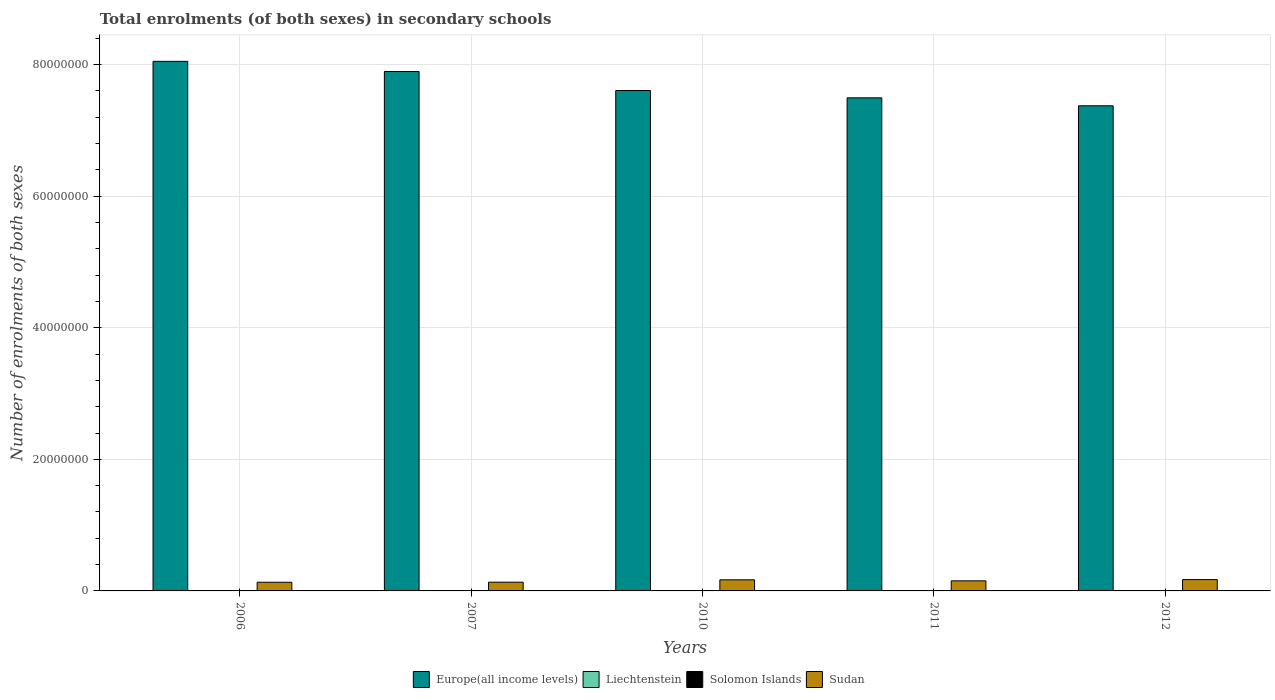How many different coloured bars are there?
Your response must be concise. 4. Are the number of bars per tick equal to the number of legend labels?
Give a very brief answer. Yes. How many bars are there on the 3rd tick from the left?
Ensure brevity in your answer.  4. How many bars are there on the 5th tick from the right?
Provide a short and direct response. 4. What is the number of enrolments in secondary schools in Liechtenstein in 2007?
Your answer should be very brief. 3169. Across all years, what is the maximum number of enrolments in secondary schools in Solomon Islands?
Your response must be concise. 4.17e+04. Across all years, what is the minimum number of enrolments in secondary schools in Liechtenstein?
Offer a terse response. 3169. In which year was the number of enrolments in secondary schools in Sudan maximum?
Give a very brief answer. 2012. What is the total number of enrolments in secondary schools in Solomon Islands in the graph?
Give a very brief answer. 1.75e+05. What is the difference between the number of enrolments in secondary schools in Europe(all income levels) in 2006 and that in 2012?
Give a very brief answer. 6.75e+06. What is the difference between the number of enrolments in secondary schools in Europe(all income levels) in 2010 and the number of enrolments in secondary schools in Sudan in 2006?
Offer a terse response. 7.47e+07. What is the average number of enrolments in secondary schools in Solomon Islands per year?
Keep it short and to the point. 3.50e+04. In the year 2006, what is the difference between the number of enrolments in secondary schools in Sudan and number of enrolments in secondary schools in Solomon Islands?
Provide a short and direct response. 1.29e+06. What is the ratio of the number of enrolments in secondary schools in Solomon Islands in 2011 to that in 2012?
Your answer should be compact. 0.96. Is the number of enrolments in secondary schools in Europe(all income levels) in 2006 less than that in 2007?
Keep it short and to the point. No. What is the difference between the highest and the second highest number of enrolments in secondary schools in Liechtenstein?
Your answer should be very brief. 21. What is the difference between the highest and the lowest number of enrolments in secondary schools in Sudan?
Your answer should be very brief. 4.06e+05. In how many years, is the number of enrolments in secondary schools in Liechtenstein greater than the average number of enrolments in secondary schools in Liechtenstein taken over all years?
Ensure brevity in your answer.  3. Is it the case that in every year, the sum of the number of enrolments in secondary schools in Europe(all income levels) and number of enrolments in secondary schools in Liechtenstein is greater than the sum of number of enrolments in secondary schools in Solomon Islands and number of enrolments in secondary schools in Sudan?
Your answer should be compact. Yes. What does the 4th bar from the left in 2012 represents?
Provide a short and direct response. Sudan. What does the 1st bar from the right in 2010 represents?
Ensure brevity in your answer.  Sudan. How many years are there in the graph?
Offer a terse response. 5. What is the difference between two consecutive major ticks on the Y-axis?
Give a very brief answer. 2.00e+07. Are the values on the major ticks of Y-axis written in scientific E-notation?
Your answer should be very brief. No. Does the graph contain any zero values?
Make the answer very short. No. What is the title of the graph?
Provide a succinct answer. Total enrolments (of both sexes) in secondary schools. Does "Bahrain" appear as one of the legend labels in the graph?
Offer a very short reply. No. What is the label or title of the Y-axis?
Your response must be concise. Number of enrolments of both sexes. What is the Number of enrolments of both sexes of Europe(all income levels) in 2006?
Your answer should be very brief. 8.05e+07. What is the Number of enrolments of both sexes in Liechtenstein in 2006?
Provide a succinct answer. 3190. What is the Number of enrolments of both sexes of Solomon Islands in 2006?
Offer a very short reply. 2.63e+04. What is the Number of enrolments of both sexes in Sudan in 2006?
Your answer should be very brief. 1.32e+06. What is the Number of enrolments of both sexes of Europe(all income levels) in 2007?
Offer a very short reply. 7.90e+07. What is the Number of enrolments of both sexes in Liechtenstein in 2007?
Make the answer very short. 3169. What is the Number of enrolments of both sexes of Solomon Islands in 2007?
Offer a very short reply. 2.73e+04. What is the Number of enrolments of both sexes of Sudan in 2007?
Ensure brevity in your answer.  1.33e+06. What is the Number of enrolments of both sexes of Europe(all income levels) in 2010?
Your answer should be compact. 7.61e+07. What is the Number of enrolments of both sexes in Liechtenstein in 2010?
Make the answer very short. 3274. What is the Number of enrolments of both sexes in Solomon Islands in 2010?
Keep it short and to the point. 3.97e+04. What is the Number of enrolments of both sexes in Sudan in 2010?
Your response must be concise. 1.69e+06. What is the Number of enrolments of both sexes in Europe(all income levels) in 2011?
Make the answer very short. 7.50e+07. What is the Number of enrolments of both sexes in Liechtenstein in 2011?
Provide a short and direct response. 3298. What is the Number of enrolments of both sexes of Solomon Islands in 2011?
Offer a very short reply. 4.01e+04. What is the Number of enrolments of both sexes of Sudan in 2011?
Keep it short and to the point. 1.53e+06. What is the Number of enrolments of both sexes in Europe(all income levels) in 2012?
Offer a very short reply. 7.37e+07. What is the Number of enrolments of both sexes of Liechtenstein in 2012?
Your response must be concise. 3277. What is the Number of enrolments of both sexes in Solomon Islands in 2012?
Your response must be concise. 4.17e+04. What is the Number of enrolments of both sexes in Sudan in 2012?
Provide a succinct answer. 1.72e+06. Across all years, what is the maximum Number of enrolments of both sexes of Europe(all income levels)?
Offer a terse response. 8.05e+07. Across all years, what is the maximum Number of enrolments of both sexes in Liechtenstein?
Keep it short and to the point. 3298. Across all years, what is the maximum Number of enrolments of both sexes in Solomon Islands?
Your answer should be very brief. 4.17e+04. Across all years, what is the maximum Number of enrolments of both sexes in Sudan?
Your answer should be compact. 1.72e+06. Across all years, what is the minimum Number of enrolments of both sexes of Europe(all income levels)?
Ensure brevity in your answer.  7.37e+07. Across all years, what is the minimum Number of enrolments of both sexes in Liechtenstein?
Offer a terse response. 3169. Across all years, what is the minimum Number of enrolments of both sexes of Solomon Islands?
Offer a very short reply. 2.63e+04. Across all years, what is the minimum Number of enrolments of both sexes in Sudan?
Provide a short and direct response. 1.32e+06. What is the total Number of enrolments of both sexes of Europe(all income levels) in the graph?
Your response must be concise. 3.84e+08. What is the total Number of enrolments of both sexes in Liechtenstein in the graph?
Ensure brevity in your answer.  1.62e+04. What is the total Number of enrolments of both sexes of Solomon Islands in the graph?
Make the answer very short. 1.75e+05. What is the total Number of enrolments of both sexes in Sudan in the graph?
Your answer should be compact. 7.59e+06. What is the difference between the Number of enrolments of both sexes in Europe(all income levels) in 2006 and that in 2007?
Offer a terse response. 1.54e+06. What is the difference between the Number of enrolments of both sexes of Liechtenstein in 2006 and that in 2007?
Offer a very short reply. 21. What is the difference between the Number of enrolments of both sexes of Solomon Islands in 2006 and that in 2007?
Offer a terse response. -987. What is the difference between the Number of enrolments of both sexes in Sudan in 2006 and that in 2007?
Ensure brevity in your answer.  -9811. What is the difference between the Number of enrolments of both sexes of Europe(all income levels) in 2006 and that in 2010?
Keep it short and to the point. 4.43e+06. What is the difference between the Number of enrolments of both sexes in Liechtenstein in 2006 and that in 2010?
Provide a short and direct response. -84. What is the difference between the Number of enrolments of both sexes in Solomon Islands in 2006 and that in 2010?
Your answer should be compact. -1.34e+04. What is the difference between the Number of enrolments of both sexes of Sudan in 2006 and that in 2010?
Your answer should be very brief. -3.69e+05. What is the difference between the Number of enrolments of both sexes in Europe(all income levels) in 2006 and that in 2011?
Your response must be concise. 5.55e+06. What is the difference between the Number of enrolments of both sexes of Liechtenstein in 2006 and that in 2011?
Make the answer very short. -108. What is the difference between the Number of enrolments of both sexes in Solomon Islands in 2006 and that in 2011?
Offer a very short reply. -1.38e+04. What is the difference between the Number of enrolments of both sexes of Sudan in 2006 and that in 2011?
Offer a terse response. -2.13e+05. What is the difference between the Number of enrolments of both sexes of Europe(all income levels) in 2006 and that in 2012?
Provide a short and direct response. 6.75e+06. What is the difference between the Number of enrolments of both sexes in Liechtenstein in 2006 and that in 2012?
Provide a succinct answer. -87. What is the difference between the Number of enrolments of both sexes of Solomon Islands in 2006 and that in 2012?
Keep it short and to the point. -1.53e+04. What is the difference between the Number of enrolments of both sexes of Sudan in 2006 and that in 2012?
Your answer should be compact. -4.06e+05. What is the difference between the Number of enrolments of both sexes of Europe(all income levels) in 2007 and that in 2010?
Make the answer very short. 2.89e+06. What is the difference between the Number of enrolments of both sexes of Liechtenstein in 2007 and that in 2010?
Your answer should be compact. -105. What is the difference between the Number of enrolments of both sexes in Solomon Islands in 2007 and that in 2010?
Your answer should be compact. -1.24e+04. What is the difference between the Number of enrolments of both sexes of Sudan in 2007 and that in 2010?
Your answer should be compact. -3.59e+05. What is the difference between the Number of enrolments of both sexes of Europe(all income levels) in 2007 and that in 2011?
Provide a short and direct response. 4.01e+06. What is the difference between the Number of enrolments of both sexes of Liechtenstein in 2007 and that in 2011?
Give a very brief answer. -129. What is the difference between the Number of enrolments of both sexes in Solomon Islands in 2007 and that in 2011?
Keep it short and to the point. -1.28e+04. What is the difference between the Number of enrolments of both sexes of Sudan in 2007 and that in 2011?
Your answer should be very brief. -2.03e+05. What is the difference between the Number of enrolments of both sexes of Europe(all income levels) in 2007 and that in 2012?
Your response must be concise. 5.21e+06. What is the difference between the Number of enrolments of both sexes of Liechtenstein in 2007 and that in 2012?
Give a very brief answer. -108. What is the difference between the Number of enrolments of both sexes of Solomon Islands in 2007 and that in 2012?
Provide a short and direct response. -1.43e+04. What is the difference between the Number of enrolments of both sexes in Sudan in 2007 and that in 2012?
Keep it short and to the point. -3.96e+05. What is the difference between the Number of enrolments of both sexes of Europe(all income levels) in 2010 and that in 2011?
Keep it short and to the point. 1.11e+06. What is the difference between the Number of enrolments of both sexes of Liechtenstein in 2010 and that in 2011?
Make the answer very short. -24. What is the difference between the Number of enrolments of both sexes in Solomon Islands in 2010 and that in 2011?
Keep it short and to the point. -418. What is the difference between the Number of enrolments of both sexes in Sudan in 2010 and that in 2011?
Keep it short and to the point. 1.57e+05. What is the difference between the Number of enrolments of both sexes of Europe(all income levels) in 2010 and that in 2012?
Offer a terse response. 2.32e+06. What is the difference between the Number of enrolments of both sexes in Liechtenstein in 2010 and that in 2012?
Give a very brief answer. -3. What is the difference between the Number of enrolments of both sexes of Solomon Islands in 2010 and that in 2012?
Your response must be concise. -1954. What is the difference between the Number of enrolments of both sexes of Sudan in 2010 and that in 2012?
Your response must be concise. -3.63e+04. What is the difference between the Number of enrolments of both sexes in Europe(all income levels) in 2011 and that in 2012?
Keep it short and to the point. 1.21e+06. What is the difference between the Number of enrolments of both sexes in Solomon Islands in 2011 and that in 2012?
Ensure brevity in your answer.  -1536. What is the difference between the Number of enrolments of both sexes in Sudan in 2011 and that in 2012?
Offer a terse response. -1.93e+05. What is the difference between the Number of enrolments of both sexes of Europe(all income levels) in 2006 and the Number of enrolments of both sexes of Liechtenstein in 2007?
Give a very brief answer. 8.05e+07. What is the difference between the Number of enrolments of both sexes in Europe(all income levels) in 2006 and the Number of enrolments of both sexes in Solomon Islands in 2007?
Keep it short and to the point. 8.05e+07. What is the difference between the Number of enrolments of both sexes of Europe(all income levels) in 2006 and the Number of enrolments of both sexes of Sudan in 2007?
Keep it short and to the point. 7.92e+07. What is the difference between the Number of enrolments of both sexes of Liechtenstein in 2006 and the Number of enrolments of both sexes of Solomon Islands in 2007?
Provide a succinct answer. -2.41e+04. What is the difference between the Number of enrolments of both sexes of Liechtenstein in 2006 and the Number of enrolments of both sexes of Sudan in 2007?
Keep it short and to the point. -1.32e+06. What is the difference between the Number of enrolments of both sexes of Solomon Islands in 2006 and the Number of enrolments of both sexes of Sudan in 2007?
Provide a short and direct response. -1.30e+06. What is the difference between the Number of enrolments of both sexes of Europe(all income levels) in 2006 and the Number of enrolments of both sexes of Liechtenstein in 2010?
Your response must be concise. 8.05e+07. What is the difference between the Number of enrolments of both sexes of Europe(all income levels) in 2006 and the Number of enrolments of both sexes of Solomon Islands in 2010?
Keep it short and to the point. 8.05e+07. What is the difference between the Number of enrolments of both sexes of Europe(all income levels) in 2006 and the Number of enrolments of both sexes of Sudan in 2010?
Keep it short and to the point. 7.88e+07. What is the difference between the Number of enrolments of both sexes in Liechtenstein in 2006 and the Number of enrolments of both sexes in Solomon Islands in 2010?
Offer a terse response. -3.65e+04. What is the difference between the Number of enrolments of both sexes of Liechtenstein in 2006 and the Number of enrolments of both sexes of Sudan in 2010?
Your response must be concise. -1.68e+06. What is the difference between the Number of enrolments of both sexes in Solomon Islands in 2006 and the Number of enrolments of both sexes in Sudan in 2010?
Offer a very short reply. -1.66e+06. What is the difference between the Number of enrolments of both sexes of Europe(all income levels) in 2006 and the Number of enrolments of both sexes of Liechtenstein in 2011?
Ensure brevity in your answer.  8.05e+07. What is the difference between the Number of enrolments of both sexes in Europe(all income levels) in 2006 and the Number of enrolments of both sexes in Solomon Islands in 2011?
Your answer should be compact. 8.05e+07. What is the difference between the Number of enrolments of both sexes of Europe(all income levels) in 2006 and the Number of enrolments of both sexes of Sudan in 2011?
Your response must be concise. 7.90e+07. What is the difference between the Number of enrolments of both sexes in Liechtenstein in 2006 and the Number of enrolments of both sexes in Solomon Islands in 2011?
Provide a succinct answer. -3.69e+04. What is the difference between the Number of enrolments of both sexes of Liechtenstein in 2006 and the Number of enrolments of both sexes of Sudan in 2011?
Keep it short and to the point. -1.53e+06. What is the difference between the Number of enrolments of both sexes of Solomon Islands in 2006 and the Number of enrolments of both sexes of Sudan in 2011?
Provide a succinct answer. -1.50e+06. What is the difference between the Number of enrolments of both sexes in Europe(all income levels) in 2006 and the Number of enrolments of both sexes in Liechtenstein in 2012?
Make the answer very short. 8.05e+07. What is the difference between the Number of enrolments of both sexes in Europe(all income levels) in 2006 and the Number of enrolments of both sexes in Solomon Islands in 2012?
Keep it short and to the point. 8.05e+07. What is the difference between the Number of enrolments of both sexes in Europe(all income levels) in 2006 and the Number of enrolments of both sexes in Sudan in 2012?
Your response must be concise. 7.88e+07. What is the difference between the Number of enrolments of both sexes of Liechtenstein in 2006 and the Number of enrolments of both sexes of Solomon Islands in 2012?
Provide a short and direct response. -3.85e+04. What is the difference between the Number of enrolments of both sexes of Liechtenstein in 2006 and the Number of enrolments of both sexes of Sudan in 2012?
Your answer should be compact. -1.72e+06. What is the difference between the Number of enrolments of both sexes in Solomon Islands in 2006 and the Number of enrolments of both sexes in Sudan in 2012?
Make the answer very short. -1.70e+06. What is the difference between the Number of enrolments of both sexes of Europe(all income levels) in 2007 and the Number of enrolments of both sexes of Liechtenstein in 2010?
Make the answer very short. 7.90e+07. What is the difference between the Number of enrolments of both sexes in Europe(all income levels) in 2007 and the Number of enrolments of both sexes in Solomon Islands in 2010?
Offer a terse response. 7.89e+07. What is the difference between the Number of enrolments of both sexes of Europe(all income levels) in 2007 and the Number of enrolments of both sexes of Sudan in 2010?
Your response must be concise. 7.73e+07. What is the difference between the Number of enrolments of both sexes in Liechtenstein in 2007 and the Number of enrolments of both sexes in Solomon Islands in 2010?
Offer a very short reply. -3.65e+04. What is the difference between the Number of enrolments of both sexes in Liechtenstein in 2007 and the Number of enrolments of both sexes in Sudan in 2010?
Give a very brief answer. -1.68e+06. What is the difference between the Number of enrolments of both sexes of Solomon Islands in 2007 and the Number of enrolments of both sexes of Sudan in 2010?
Give a very brief answer. -1.66e+06. What is the difference between the Number of enrolments of both sexes in Europe(all income levels) in 2007 and the Number of enrolments of both sexes in Liechtenstein in 2011?
Your response must be concise. 7.90e+07. What is the difference between the Number of enrolments of both sexes in Europe(all income levels) in 2007 and the Number of enrolments of both sexes in Solomon Islands in 2011?
Your answer should be compact. 7.89e+07. What is the difference between the Number of enrolments of both sexes of Europe(all income levels) in 2007 and the Number of enrolments of both sexes of Sudan in 2011?
Your response must be concise. 7.74e+07. What is the difference between the Number of enrolments of both sexes in Liechtenstein in 2007 and the Number of enrolments of both sexes in Solomon Islands in 2011?
Give a very brief answer. -3.70e+04. What is the difference between the Number of enrolments of both sexes of Liechtenstein in 2007 and the Number of enrolments of both sexes of Sudan in 2011?
Give a very brief answer. -1.53e+06. What is the difference between the Number of enrolments of both sexes of Solomon Islands in 2007 and the Number of enrolments of both sexes of Sudan in 2011?
Ensure brevity in your answer.  -1.50e+06. What is the difference between the Number of enrolments of both sexes of Europe(all income levels) in 2007 and the Number of enrolments of both sexes of Liechtenstein in 2012?
Offer a very short reply. 7.90e+07. What is the difference between the Number of enrolments of both sexes in Europe(all income levels) in 2007 and the Number of enrolments of both sexes in Solomon Islands in 2012?
Your response must be concise. 7.89e+07. What is the difference between the Number of enrolments of both sexes in Europe(all income levels) in 2007 and the Number of enrolments of both sexes in Sudan in 2012?
Your answer should be very brief. 7.72e+07. What is the difference between the Number of enrolments of both sexes of Liechtenstein in 2007 and the Number of enrolments of both sexes of Solomon Islands in 2012?
Your response must be concise. -3.85e+04. What is the difference between the Number of enrolments of both sexes in Liechtenstein in 2007 and the Number of enrolments of both sexes in Sudan in 2012?
Make the answer very short. -1.72e+06. What is the difference between the Number of enrolments of both sexes in Solomon Islands in 2007 and the Number of enrolments of both sexes in Sudan in 2012?
Provide a short and direct response. -1.70e+06. What is the difference between the Number of enrolments of both sexes in Europe(all income levels) in 2010 and the Number of enrolments of both sexes in Liechtenstein in 2011?
Provide a succinct answer. 7.61e+07. What is the difference between the Number of enrolments of both sexes of Europe(all income levels) in 2010 and the Number of enrolments of both sexes of Solomon Islands in 2011?
Provide a short and direct response. 7.60e+07. What is the difference between the Number of enrolments of both sexes in Europe(all income levels) in 2010 and the Number of enrolments of both sexes in Sudan in 2011?
Give a very brief answer. 7.45e+07. What is the difference between the Number of enrolments of both sexes in Liechtenstein in 2010 and the Number of enrolments of both sexes in Solomon Islands in 2011?
Ensure brevity in your answer.  -3.68e+04. What is the difference between the Number of enrolments of both sexes in Liechtenstein in 2010 and the Number of enrolments of both sexes in Sudan in 2011?
Offer a terse response. -1.53e+06. What is the difference between the Number of enrolments of both sexes in Solomon Islands in 2010 and the Number of enrolments of both sexes in Sudan in 2011?
Provide a succinct answer. -1.49e+06. What is the difference between the Number of enrolments of both sexes of Europe(all income levels) in 2010 and the Number of enrolments of both sexes of Liechtenstein in 2012?
Your response must be concise. 7.61e+07. What is the difference between the Number of enrolments of both sexes of Europe(all income levels) in 2010 and the Number of enrolments of both sexes of Solomon Islands in 2012?
Your answer should be very brief. 7.60e+07. What is the difference between the Number of enrolments of both sexes of Europe(all income levels) in 2010 and the Number of enrolments of both sexes of Sudan in 2012?
Your answer should be compact. 7.43e+07. What is the difference between the Number of enrolments of both sexes of Liechtenstein in 2010 and the Number of enrolments of both sexes of Solomon Islands in 2012?
Offer a terse response. -3.84e+04. What is the difference between the Number of enrolments of both sexes in Liechtenstein in 2010 and the Number of enrolments of both sexes in Sudan in 2012?
Offer a terse response. -1.72e+06. What is the difference between the Number of enrolments of both sexes in Solomon Islands in 2010 and the Number of enrolments of both sexes in Sudan in 2012?
Your answer should be very brief. -1.68e+06. What is the difference between the Number of enrolments of both sexes of Europe(all income levels) in 2011 and the Number of enrolments of both sexes of Liechtenstein in 2012?
Offer a terse response. 7.49e+07. What is the difference between the Number of enrolments of both sexes in Europe(all income levels) in 2011 and the Number of enrolments of both sexes in Solomon Islands in 2012?
Your answer should be compact. 7.49e+07. What is the difference between the Number of enrolments of both sexes of Europe(all income levels) in 2011 and the Number of enrolments of both sexes of Sudan in 2012?
Your response must be concise. 7.32e+07. What is the difference between the Number of enrolments of both sexes of Liechtenstein in 2011 and the Number of enrolments of both sexes of Solomon Islands in 2012?
Offer a terse response. -3.84e+04. What is the difference between the Number of enrolments of both sexes of Liechtenstein in 2011 and the Number of enrolments of both sexes of Sudan in 2012?
Offer a very short reply. -1.72e+06. What is the difference between the Number of enrolments of both sexes in Solomon Islands in 2011 and the Number of enrolments of both sexes in Sudan in 2012?
Offer a very short reply. -1.68e+06. What is the average Number of enrolments of both sexes of Europe(all income levels) per year?
Offer a very short reply. 7.68e+07. What is the average Number of enrolments of both sexes in Liechtenstein per year?
Ensure brevity in your answer.  3241.6. What is the average Number of enrolments of both sexes of Solomon Islands per year?
Your answer should be very brief. 3.50e+04. What is the average Number of enrolments of both sexes in Sudan per year?
Provide a short and direct response. 1.52e+06. In the year 2006, what is the difference between the Number of enrolments of both sexes in Europe(all income levels) and Number of enrolments of both sexes in Liechtenstein?
Your answer should be very brief. 8.05e+07. In the year 2006, what is the difference between the Number of enrolments of both sexes of Europe(all income levels) and Number of enrolments of both sexes of Solomon Islands?
Offer a very short reply. 8.05e+07. In the year 2006, what is the difference between the Number of enrolments of both sexes in Europe(all income levels) and Number of enrolments of both sexes in Sudan?
Your answer should be compact. 7.92e+07. In the year 2006, what is the difference between the Number of enrolments of both sexes in Liechtenstein and Number of enrolments of both sexes in Solomon Islands?
Keep it short and to the point. -2.32e+04. In the year 2006, what is the difference between the Number of enrolments of both sexes of Liechtenstein and Number of enrolments of both sexes of Sudan?
Your answer should be compact. -1.31e+06. In the year 2006, what is the difference between the Number of enrolments of both sexes in Solomon Islands and Number of enrolments of both sexes in Sudan?
Provide a succinct answer. -1.29e+06. In the year 2007, what is the difference between the Number of enrolments of both sexes of Europe(all income levels) and Number of enrolments of both sexes of Liechtenstein?
Provide a short and direct response. 7.90e+07. In the year 2007, what is the difference between the Number of enrolments of both sexes of Europe(all income levels) and Number of enrolments of both sexes of Solomon Islands?
Keep it short and to the point. 7.89e+07. In the year 2007, what is the difference between the Number of enrolments of both sexes in Europe(all income levels) and Number of enrolments of both sexes in Sudan?
Provide a succinct answer. 7.76e+07. In the year 2007, what is the difference between the Number of enrolments of both sexes in Liechtenstein and Number of enrolments of both sexes in Solomon Islands?
Provide a short and direct response. -2.42e+04. In the year 2007, what is the difference between the Number of enrolments of both sexes in Liechtenstein and Number of enrolments of both sexes in Sudan?
Provide a succinct answer. -1.32e+06. In the year 2007, what is the difference between the Number of enrolments of both sexes of Solomon Islands and Number of enrolments of both sexes of Sudan?
Provide a short and direct response. -1.30e+06. In the year 2010, what is the difference between the Number of enrolments of both sexes in Europe(all income levels) and Number of enrolments of both sexes in Liechtenstein?
Your answer should be very brief. 7.61e+07. In the year 2010, what is the difference between the Number of enrolments of both sexes of Europe(all income levels) and Number of enrolments of both sexes of Solomon Islands?
Provide a succinct answer. 7.60e+07. In the year 2010, what is the difference between the Number of enrolments of both sexes in Europe(all income levels) and Number of enrolments of both sexes in Sudan?
Offer a very short reply. 7.44e+07. In the year 2010, what is the difference between the Number of enrolments of both sexes in Liechtenstein and Number of enrolments of both sexes in Solomon Islands?
Give a very brief answer. -3.64e+04. In the year 2010, what is the difference between the Number of enrolments of both sexes of Liechtenstein and Number of enrolments of both sexes of Sudan?
Your answer should be compact. -1.68e+06. In the year 2010, what is the difference between the Number of enrolments of both sexes of Solomon Islands and Number of enrolments of both sexes of Sudan?
Ensure brevity in your answer.  -1.65e+06. In the year 2011, what is the difference between the Number of enrolments of both sexes in Europe(all income levels) and Number of enrolments of both sexes in Liechtenstein?
Your answer should be compact. 7.49e+07. In the year 2011, what is the difference between the Number of enrolments of both sexes of Europe(all income levels) and Number of enrolments of both sexes of Solomon Islands?
Make the answer very short. 7.49e+07. In the year 2011, what is the difference between the Number of enrolments of both sexes of Europe(all income levels) and Number of enrolments of both sexes of Sudan?
Keep it short and to the point. 7.34e+07. In the year 2011, what is the difference between the Number of enrolments of both sexes of Liechtenstein and Number of enrolments of both sexes of Solomon Islands?
Offer a very short reply. -3.68e+04. In the year 2011, what is the difference between the Number of enrolments of both sexes of Liechtenstein and Number of enrolments of both sexes of Sudan?
Ensure brevity in your answer.  -1.53e+06. In the year 2011, what is the difference between the Number of enrolments of both sexes in Solomon Islands and Number of enrolments of both sexes in Sudan?
Provide a succinct answer. -1.49e+06. In the year 2012, what is the difference between the Number of enrolments of both sexes of Europe(all income levels) and Number of enrolments of both sexes of Liechtenstein?
Offer a terse response. 7.37e+07. In the year 2012, what is the difference between the Number of enrolments of both sexes in Europe(all income levels) and Number of enrolments of both sexes in Solomon Islands?
Provide a succinct answer. 7.37e+07. In the year 2012, what is the difference between the Number of enrolments of both sexes of Europe(all income levels) and Number of enrolments of both sexes of Sudan?
Your answer should be very brief. 7.20e+07. In the year 2012, what is the difference between the Number of enrolments of both sexes in Liechtenstein and Number of enrolments of both sexes in Solomon Islands?
Your response must be concise. -3.84e+04. In the year 2012, what is the difference between the Number of enrolments of both sexes of Liechtenstein and Number of enrolments of both sexes of Sudan?
Your answer should be compact. -1.72e+06. In the year 2012, what is the difference between the Number of enrolments of both sexes of Solomon Islands and Number of enrolments of both sexes of Sudan?
Offer a terse response. -1.68e+06. What is the ratio of the Number of enrolments of both sexes in Europe(all income levels) in 2006 to that in 2007?
Your answer should be compact. 1.02. What is the ratio of the Number of enrolments of both sexes of Liechtenstein in 2006 to that in 2007?
Provide a succinct answer. 1.01. What is the ratio of the Number of enrolments of both sexes of Solomon Islands in 2006 to that in 2007?
Offer a very short reply. 0.96. What is the ratio of the Number of enrolments of both sexes of Europe(all income levels) in 2006 to that in 2010?
Your answer should be compact. 1.06. What is the ratio of the Number of enrolments of both sexes of Liechtenstein in 2006 to that in 2010?
Provide a short and direct response. 0.97. What is the ratio of the Number of enrolments of both sexes in Solomon Islands in 2006 to that in 2010?
Your answer should be compact. 0.66. What is the ratio of the Number of enrolments of both sexes of Sudan in 2006 to that in 2010?
Offer a terse response. 0.78. What is the ratio of the Number of enrolments of both sexes in Europe(all income levels) in 2006 to that in 2011?
Your response must be concise. 1.07. What is the ratio of the Number of enrolments of both sexes of Liechtenstein in 2006 to that in 2011?
Your response must be concise. 0.97. What is the ratio of the Number of enrolments of both sexes in Solomon Islands in 2006 to that in 2011?
Make the answer very short. 0.66. What is the ratio of the Number of enrolments of both sexes of Sudan in 2006 to that in 2011?
Provide a succinct answer. 0.86. What is the ratio of the Number of enrolments of both sexes of Europe(all income levels) in 2006 to that in 2012?
Offer a very short reply. 1.09. What is the ratio of the Number of enrolments of both sexes in Liechtenstein in 2006 to that in 2012?
Keep it short and to the point. 0.97. What is the ratio of the Number of enrolments of both sexes of Solomon Islands in 2006 to that in 2012?
Offer a very short reply. 0.63. What is the ratio of the Number of enrolments of both sexes in Sudan in 2006 to that in 2012?
Keep it short and to the point. 0.76. What is the ratio of the Number of enrolments of both sexes in Europe(all income levels) in 2007 to that in 2010?
Your response must be concise. 1.04. What is the ratio of the Number of enrolments of both sexes of Liechtenstein in 2007 to that in 2010?
Make the answer very short. 0.97. What is the ratio of the Number of enrolments of both sexes in Solomon Islands in 2007 to that in 2010?
Offer a terse response. 0.69. What is the ratio of the Number of enrolments of both sexes of Sudan in 2007 to that in 2010?
Offer a very short reply. 0.79. What is the ratio of the Number of enrolments of both sexes in Europe(all income levels) in 2007 to that in 2011?
Keep it short and to the point. 1.05. What is the ratio of the Number of enrolments of both sexes of Liechtenstein in 2007 to that in 2011?
Keep it short and to the point. 0.96. What is the ratio of the Number of enrolments of both sexes of Solomon Islands in 2007 to that in 2011?
Provide a short and direct response. 0.68. What is the ratio of the Number of enrolments of both sexes in Sudan in 2007 to that in 2011?
Provide a succinct answer. 0.87. What is the ratio of the Number of enrolments of both sexes of Europe(all income levels) in 2007 to that in 2012?
Offer a very short reply. 1.07. What is the ratio of the Number of enrolments of both sexes in Solomon Islands in 2007 to that in 2012?
Offer a very short reply. 0.66. What is the ratio of the Number of enrolments of both sexes of Sudan in 2007 to that in 2012?
Give a very brief answer. 0.77. What is the ratio of the Number of enrolments of both sexes of Europe(all income levels) in 2010 to that in 2011?
Your answer should be compact. 1.01. What is the ratio of the Number of enrolments of both sexes of Solomon Islands in 2010 to that in 2011?
Provide a short and direct response. 0.99. What is the ratio of the Number of enrolments of both sexes of Sudan in 2010 to that in 2011?
Give a very brief answer. 1.1. What is the ratio of the Number of enrolments of both sexes of Europe(all income levels) in 2010 to that in 2012?
Offer a terse response. 1.03. What is the ratio of the Number of enrolments of both sexes of Liechtenstein in 2010 to that in 2012?
Provide a short and direct response. 1. What is the ratio of the Number of enrolments of both sexes in Solomon Islands in 2010 to that in 2012?
Ensure brevity in your answer.  0.95. What is the ratio of the Number of enrolments of both sexes of Sudan in 2010 to that in 2012?
Offer a terse response. 0.98. What is the ratio of the Number of enrolments of both sexes in Europe(all income levels) in 2011 to that in 2012?
Your answer should be very brief. 1.02. What is the ratio of the Number of enrolments of both sexes in Liechtenstein in 2011 to that in 2012?
Your response must be concise. 1.01. What is the ratio of the Number of enrolments of both sexes of Solomon Islands in 2011 to that in 2012?
Your answer should be very brief. 0.96. What is the ratio of the Number of enrolments of both sexes in Sudan in 2011 to that in 2012?
Provide a succinct answer. 0.89. What is the difference between the highest and the second highest Number of enrolments of both sexes of Europe(all income levels)?
Offer a terse response. 1.54e+06. What is the difference between the highest and the second highest Number of enrolments of both sexes in Solomon Islands?
Your response must be concise. 1536. What is the difference between the highest and the second highest Number of enrolments of both sexes in Sudan?
Keep it short and to the point. 3.63e+04. What is the difference between the highest and the lowest Number of enrolments of both sexes in Europe(all income levels)?
Provide a succinct answer. 6.75e+06. What is the difference between the highest and the lowest Number of enrolments of both sexes in Liechtenstein?
Offer a terse response. 129. What is the difference between the highest and the lowest Number of enrolments of both sexes in Solomon Islands?
Your response must be concise. 1.53e+04. What is the difference between the highest and the lowest Number of enrolments of both sexes in Sudan?
Your answer should be very brief. 4.06e+05. 